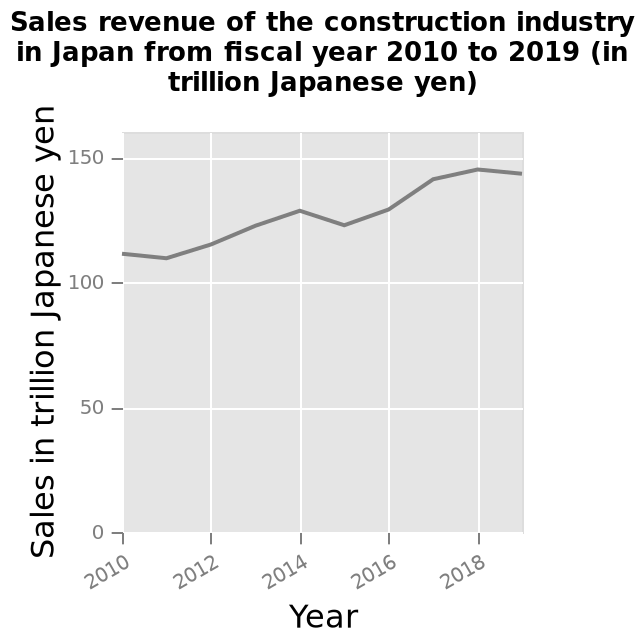<image>
Has there been any period of decline in sales for the construction industry from 2010 to 2019? Yes, there was a slight dip in sales for the construction industry in 2015, but overall, the sales have risen between 2010 and 2019. What is the range of the y-axis? The range of the y-axis is from 0 to 150 trillion Japanese yen. Has the sales of the construction industry consistently increased during the period of 2010 to 2019? Yes, apart from a slight dip in 2015, the sales of the construction industry have experienced a consistent increase from 2010 to 2019. What is the title of the line chart? The title of the line chart is "Sales revenue of the construction industry in Japan from fiscal year 2010 to 2019 (in trillion Japanese yen)". 